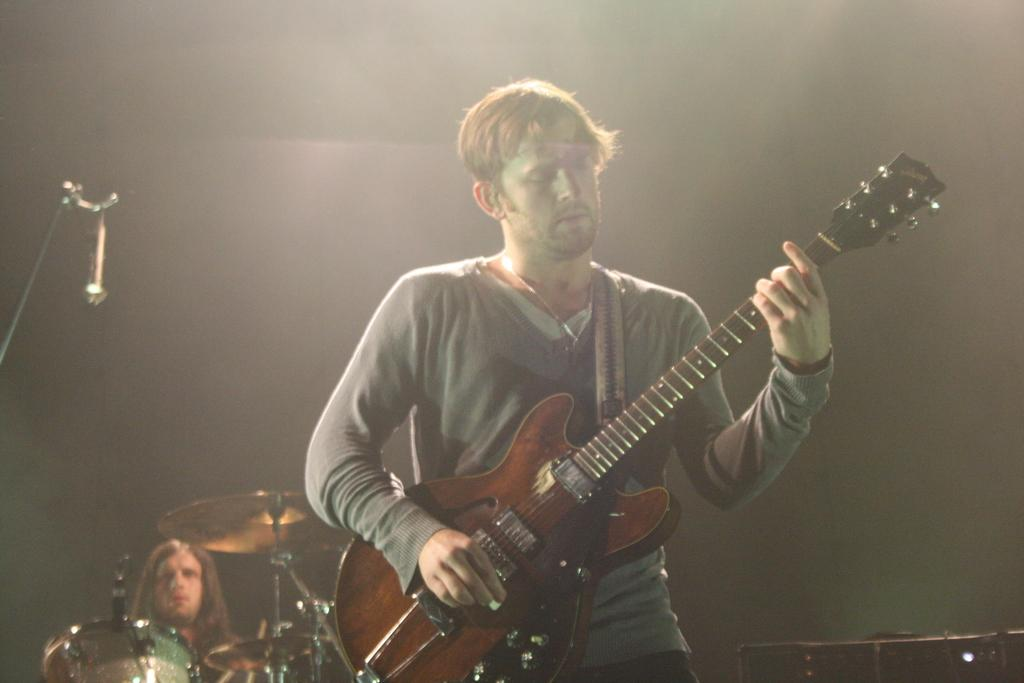What is the man in the image doing? The man is playing a guitar. Are there any other people in the image? Yes, there is a man seated in the image. What is the seated man doing? The seated man is playing drums. How many cars can be seen in the image? There are no cars present in the image. What type of cloud is visible in the image? There is no cloud visible in the image. 